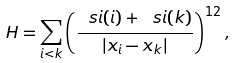Convert formula to latex. <formula><loc_0><loc_0><loc_500><loc_500>H = \sum _ { i < k } \left ( \frac { \ s i ( i ) + \ s i ( k ) } { | { x } _ { i } - { x } _ { k } | } \right ) ^ { 1 2 } ,</formula> 